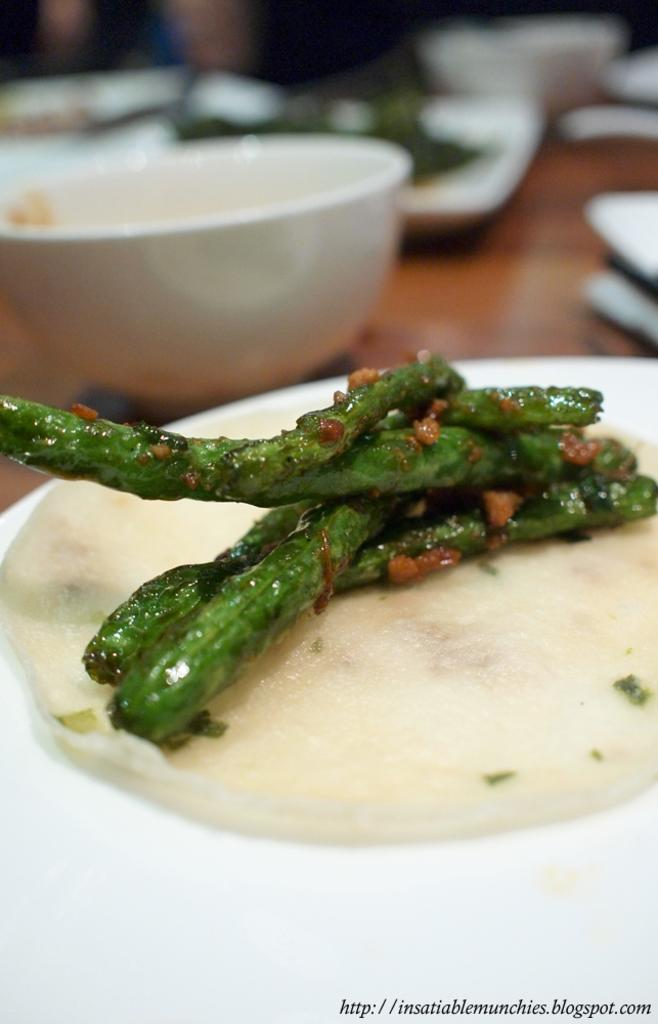What is the main subject of the image? There is food in the image. Can you describe the background of the image? The background is blurry. What objects can be seen in the background? There are plates and bowls in the background. Is there a volcano erupting in the background of the image? No, there is no volcano present in the image. What type of cannon can be seen in the image? There is no cannon present in the image. 